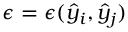<formula> <loc_0><loc_0><loc_500><loc_500>\epsilon = \epsilon ( \hat { y } _ { i } , \hat { y } _ { j } )</formula> 